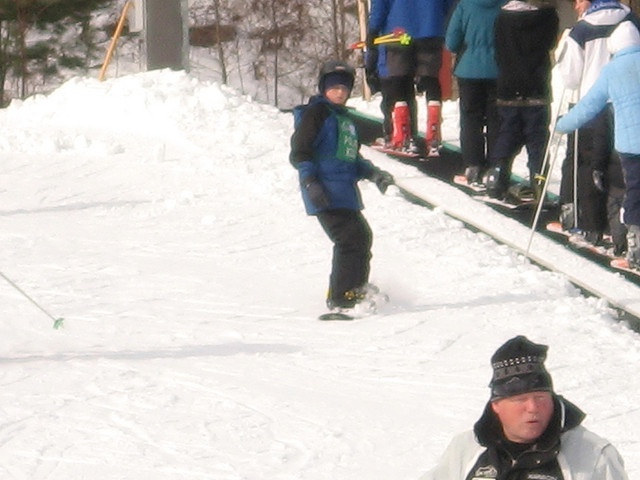Describe the objects in this image and their specific colors. I can see people in darkgreen, black, gray, lightgray, and darkgray tones, people in darkgreen, gray, black, blue, and navy tones, people in darkgreen, white, black, gray, and darkgray tones, people in darkgreen, black, gray, and darkgray tones, and people in darkgreen, black, gray, blue, and navy tones in this image. 